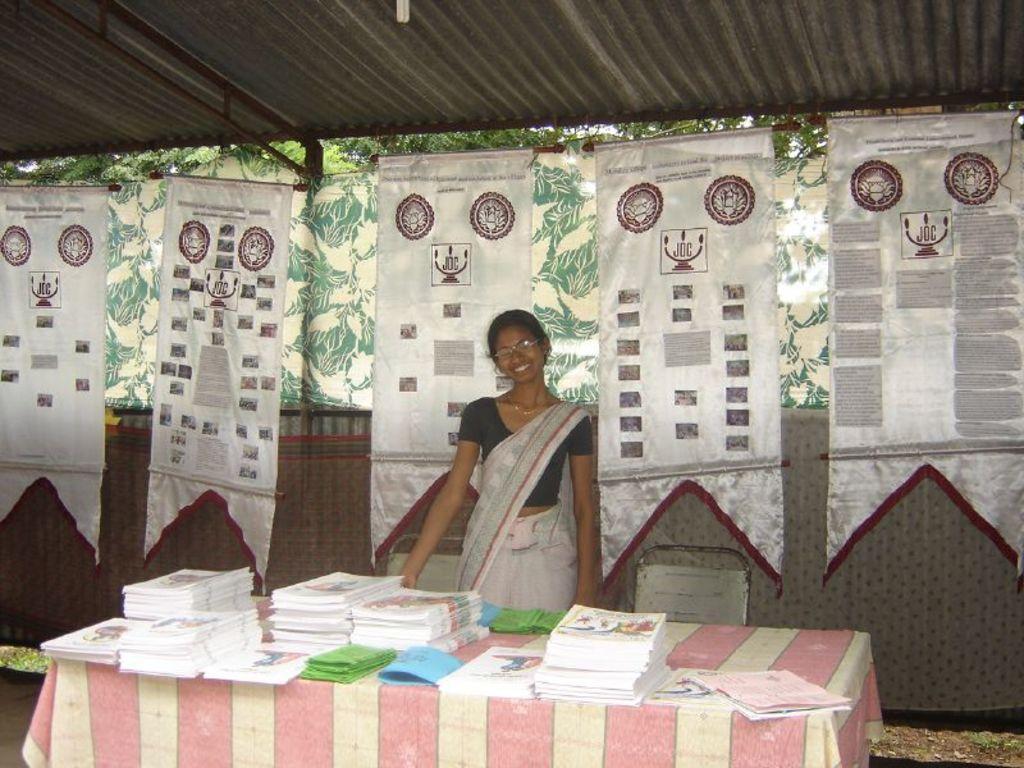How would you summarize this image in a sentence or two? In this picture we can see a woman wore spectacles, smiling and in front of her we can see books, cloth on the table and at the back of her we can see chairs, banners, trees, roof, cloth. 